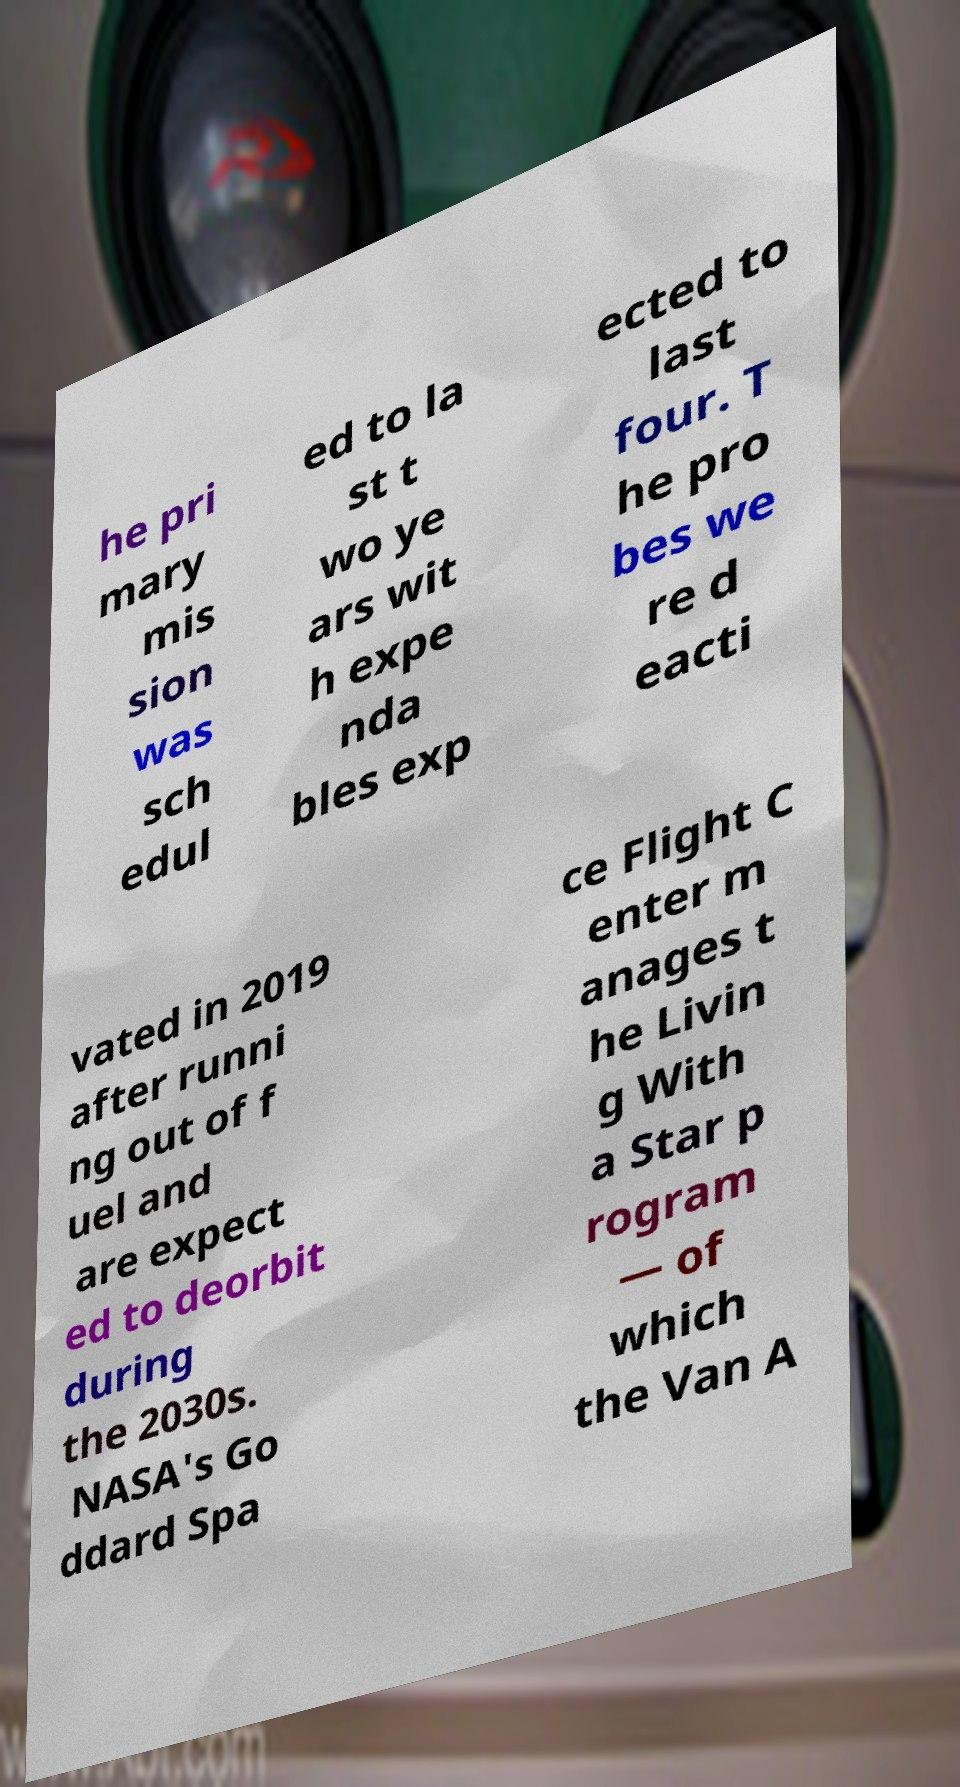Can you accurately transcribe the text from the provided image for me? he pri mary mis sion was sch edul ed to la st t wo ye ars wit h expe nda bles exp ected to last four. T he pro bes we re d eacti vated in 2019 after runni ng out of f uel and are expect ed to deorbit during the 2030s. NASA's Go ddard Spa ce Flight C enter m anages t he Livin g With a Star p rogram — of which the Van A 